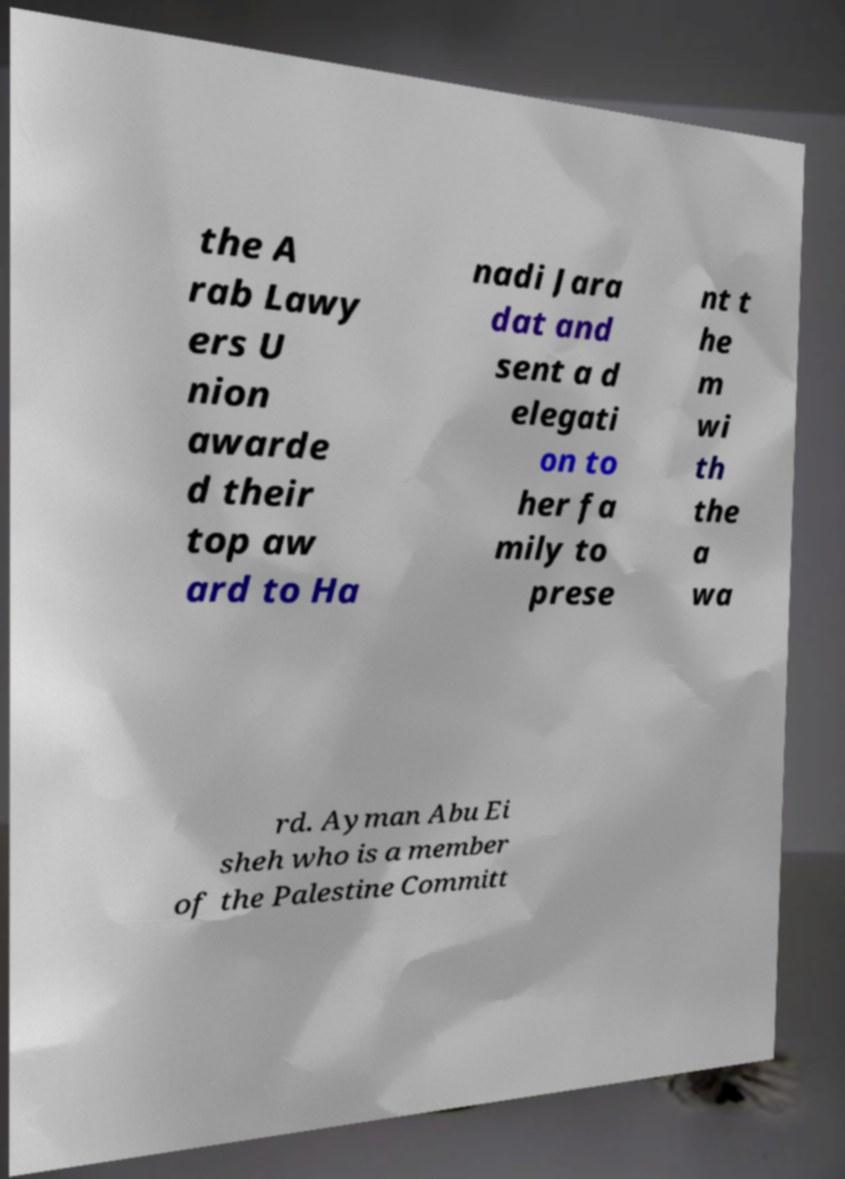Could you assist in decoding the text presented in this image and type it out clearly? the A rab Lawy ers U nion awarde d their top aw ard to Ha nadi Jara dat and sent a d elegati on to her fa mily to prese nt t he m wi th the a wa rd. Ayman Abu Ei sheh who is a member of the Palestine Committ 